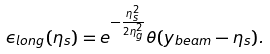<formula> <loc_0><loc_0><loc_500><loc_500>\epsilon _ { l o n g } ( \eta _ { s } ) = e ^ { - \frac { \eta _ { s } ^ { 2 } } { 2 \eta _ { g } ^ { 2 } } } \theta ( y _ { b e a m } - \eta _ { s } ) .</formula> 